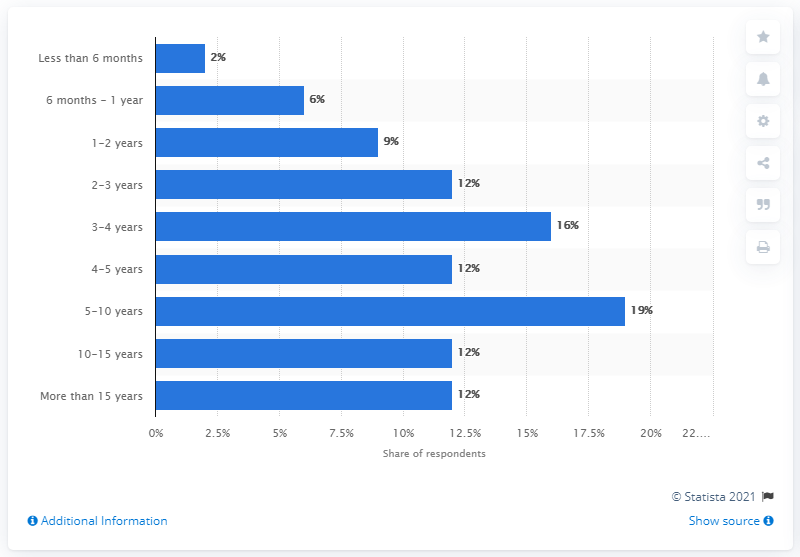Identify some key points in this picture. Approximately 24% of the staff have been employed at the company for 10 years or more. The shortest bar is 2. 